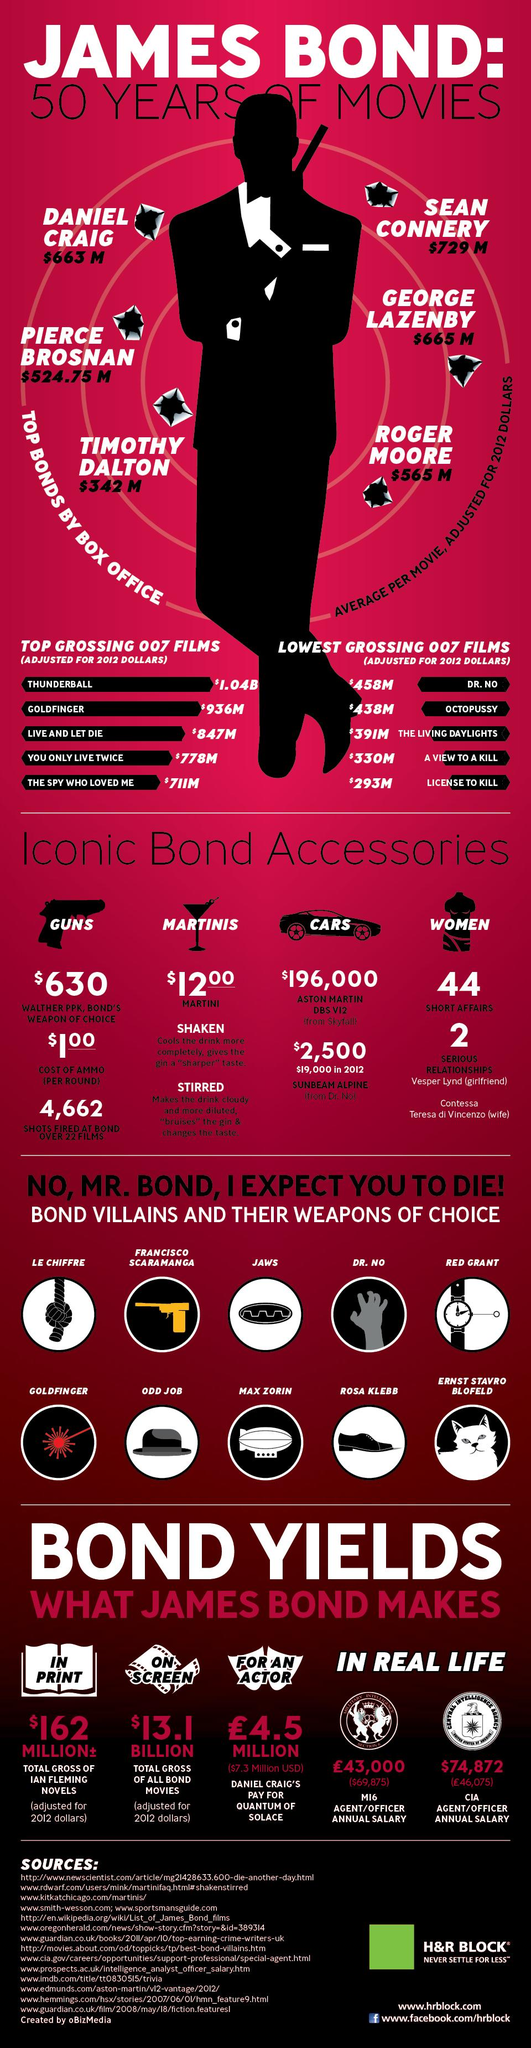Identify some key points in this picture. The film 'The Spy Who Loved Me' came in fifth among the top grossing 007 films. George Lazenby, an actor who played Bond, earned the second most at the box office among all the actors who portrayed Bond. The film 'Octopussy' came in fourth among the lowest-grossing 007 films. Daniel Craig, the actor who portrayed James Bond, came in third in terms of box office earnings among the Bond actors. The film "The Living Daylights" ranked third among the lowest-grossing 007 films. 